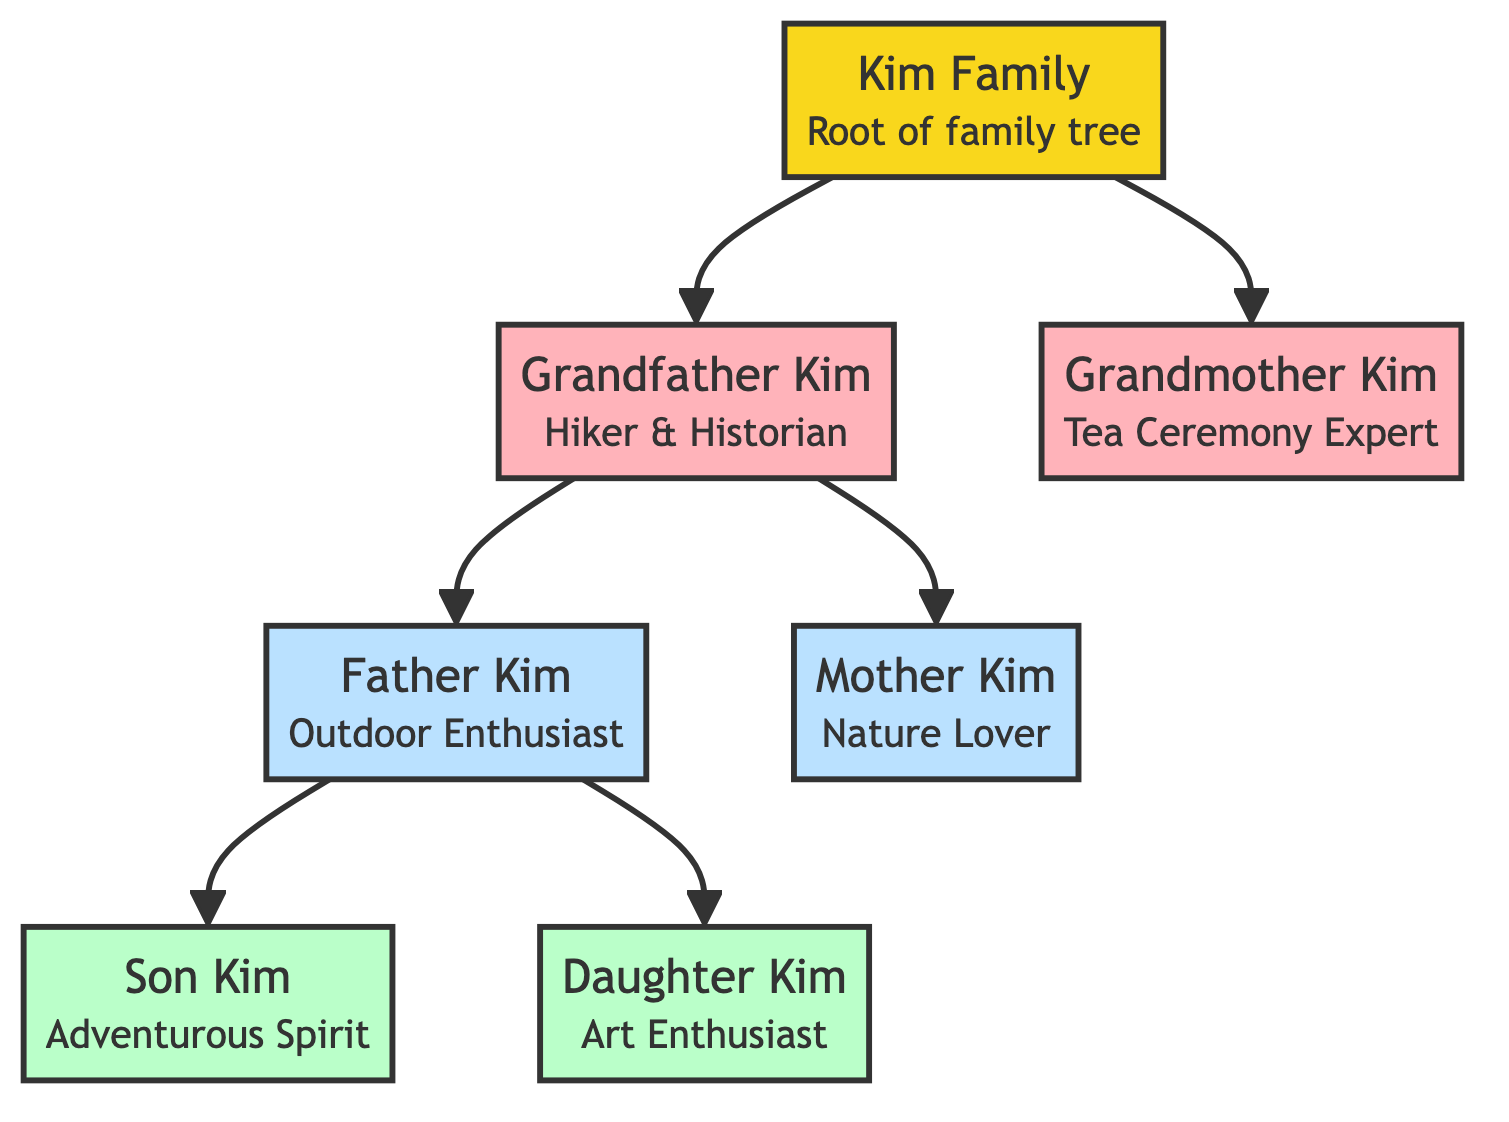What is the root of the family tree? The root node of the diagram is "Kim Family," as indicated at the top of the flowchart.
Answer: Kim Family Who is the outdoor enthusiast in the second generation? In the diagram, "Father Kim" is described as an outdoor enthusiast, linking him to the second generation.
Answer: Father Kim How many nodes are in the diagram? Counting each family member and the root, there are 7 nodes in total within the family tree.
Answer: 7 Which activity does Grandfather Kim enjoy? According to the description, Grandfather Kim enjoys trekking in Seoraksan National Park.
Answer: Trekking in Seoraksan National Park Who are the children of Father Kim? Moving from Father Kim, the two children listed are "Son Kim" and "Daughter Kim," signifying their direct relationship.
Answer: Son Kim, Daughter Kim What relationship exists between Grandfather Kim and Mother Kim? Tracing the edges in the diagram, Grandfather Kim is the parent of Mother Kim, marking a direct lineage statement.
Answer: Parent Which family member is the tea ceremony expert? The description directly states that Grandmother Kim is an expert in traditional Korean tea ceremonies.
Answer: Grandmother Kim What is the total number of edges connecting the family members? By examining the lines in the diagram, there are 6 edges shown connecting different family relationships.
Answer: 6 Which historical site does Daughter Kim love to visit? The diagram states that Daughter Kim loves visiting Gyeongbokgung Palace, a significant cultural and historical site.
Answer: Gyeongbokgung Palace 